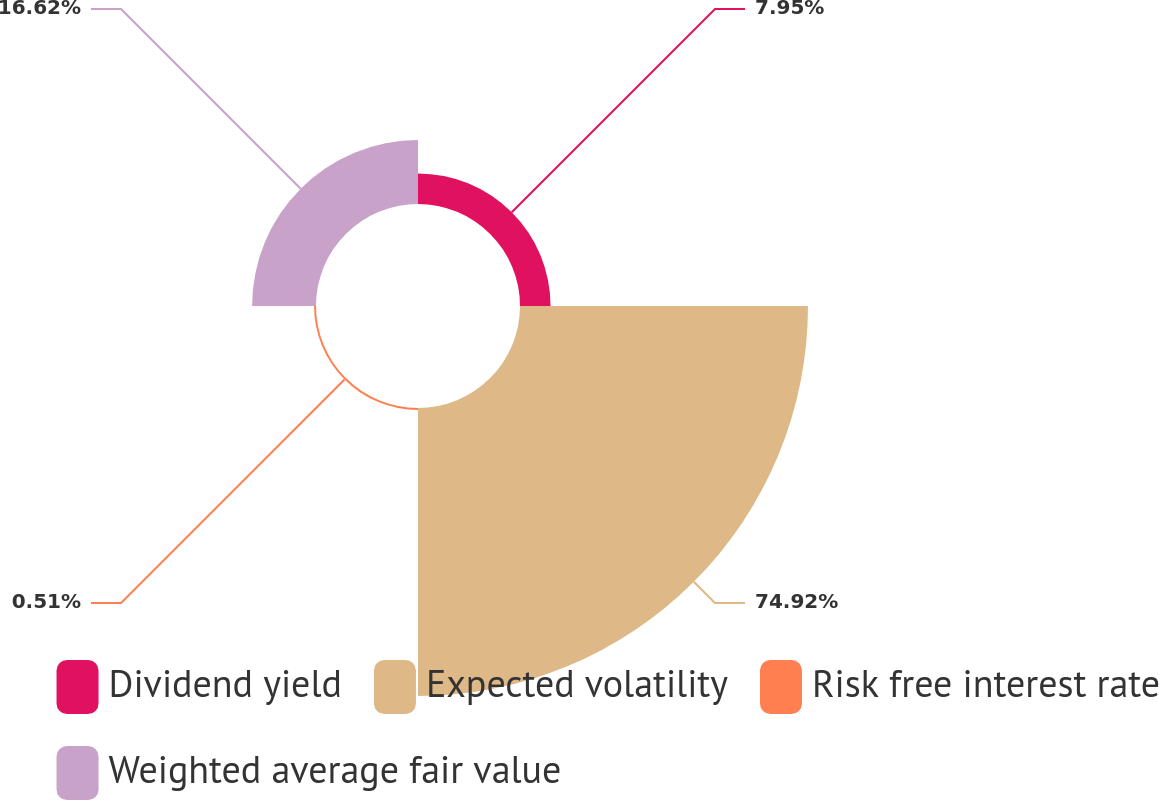Convert chart to OTSL. <chart><loc_0><loc_0><loc_500><loc_500><pie_chart><fcel>Dividend yield<fcel>Expected volatility<fcel>Risk free interest rate<fcel>Weighted average fair value<nl><fcel>7.95%<fcel>74.92%<fcel>0.51%<fcel>16.62%<nl></chart> 